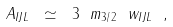Convert formula to latex. <formula><loc_0><loc_0><loc_500><loc_500>A _ { I J L } \ \simeq \ 3 \ m _ { 3 / 2 } \ w _ { I J L } \ ,</formula> 